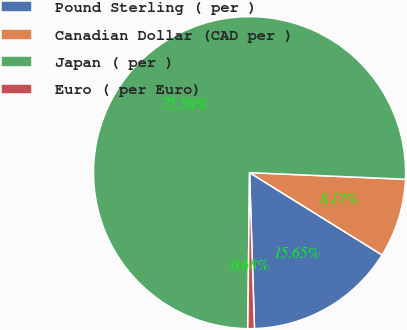Convert chart to OTSL. <chart><loc_0><loc_0><loc_500><loc_500><pie_chart><fcel>Pound Sterling ( per )<fcel>Canadian Dollar (CAD per )<fcel>Japan ( per )<fcel>Euro ( per Euro)<nl><fcel>15.65%<fcel>8.17%<fcel>75.5%<fcel>0.68%<nl></chart> 